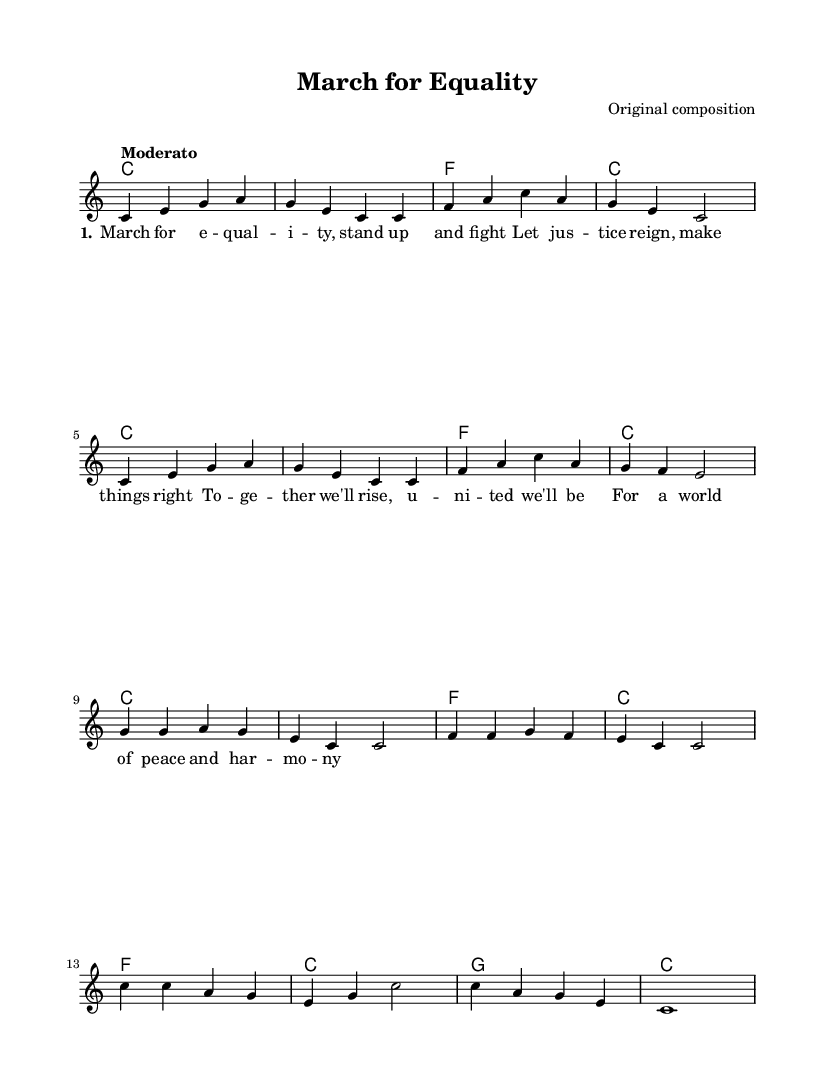What is the key signature of this music? The key signature is C major, which has no sharps or flats.
Answer: C major What is the time signature of this music? The time signature is indicated by "4/4," meaning there are four beats in each measure, and the quarter note receives one beat.
Answer: 4/4 What is the tempo marking indicated in this music? The tempo is marked as "Moderato," suggesting a moderate pace for the piece.
Answer: Moderato How many measures does this piece contain? By counting the measures in the staff, there are a total of 16 measures in this composition.
Answer: 16 What is the title of the piece? The title "March for Equality" is indicated in the header section of the sheet music.
Answer: March for Equality What lyrical theme is addressed in this song? The lyrics discuss the themes of justice, unity, and the desire for a peaceful world, reflecting social equality and harmony.
Answer: Equality How many vocal lines are present in this score? The score features one vocal line, as indicated by the "new Voice" label for the lead part.
Answer: One 